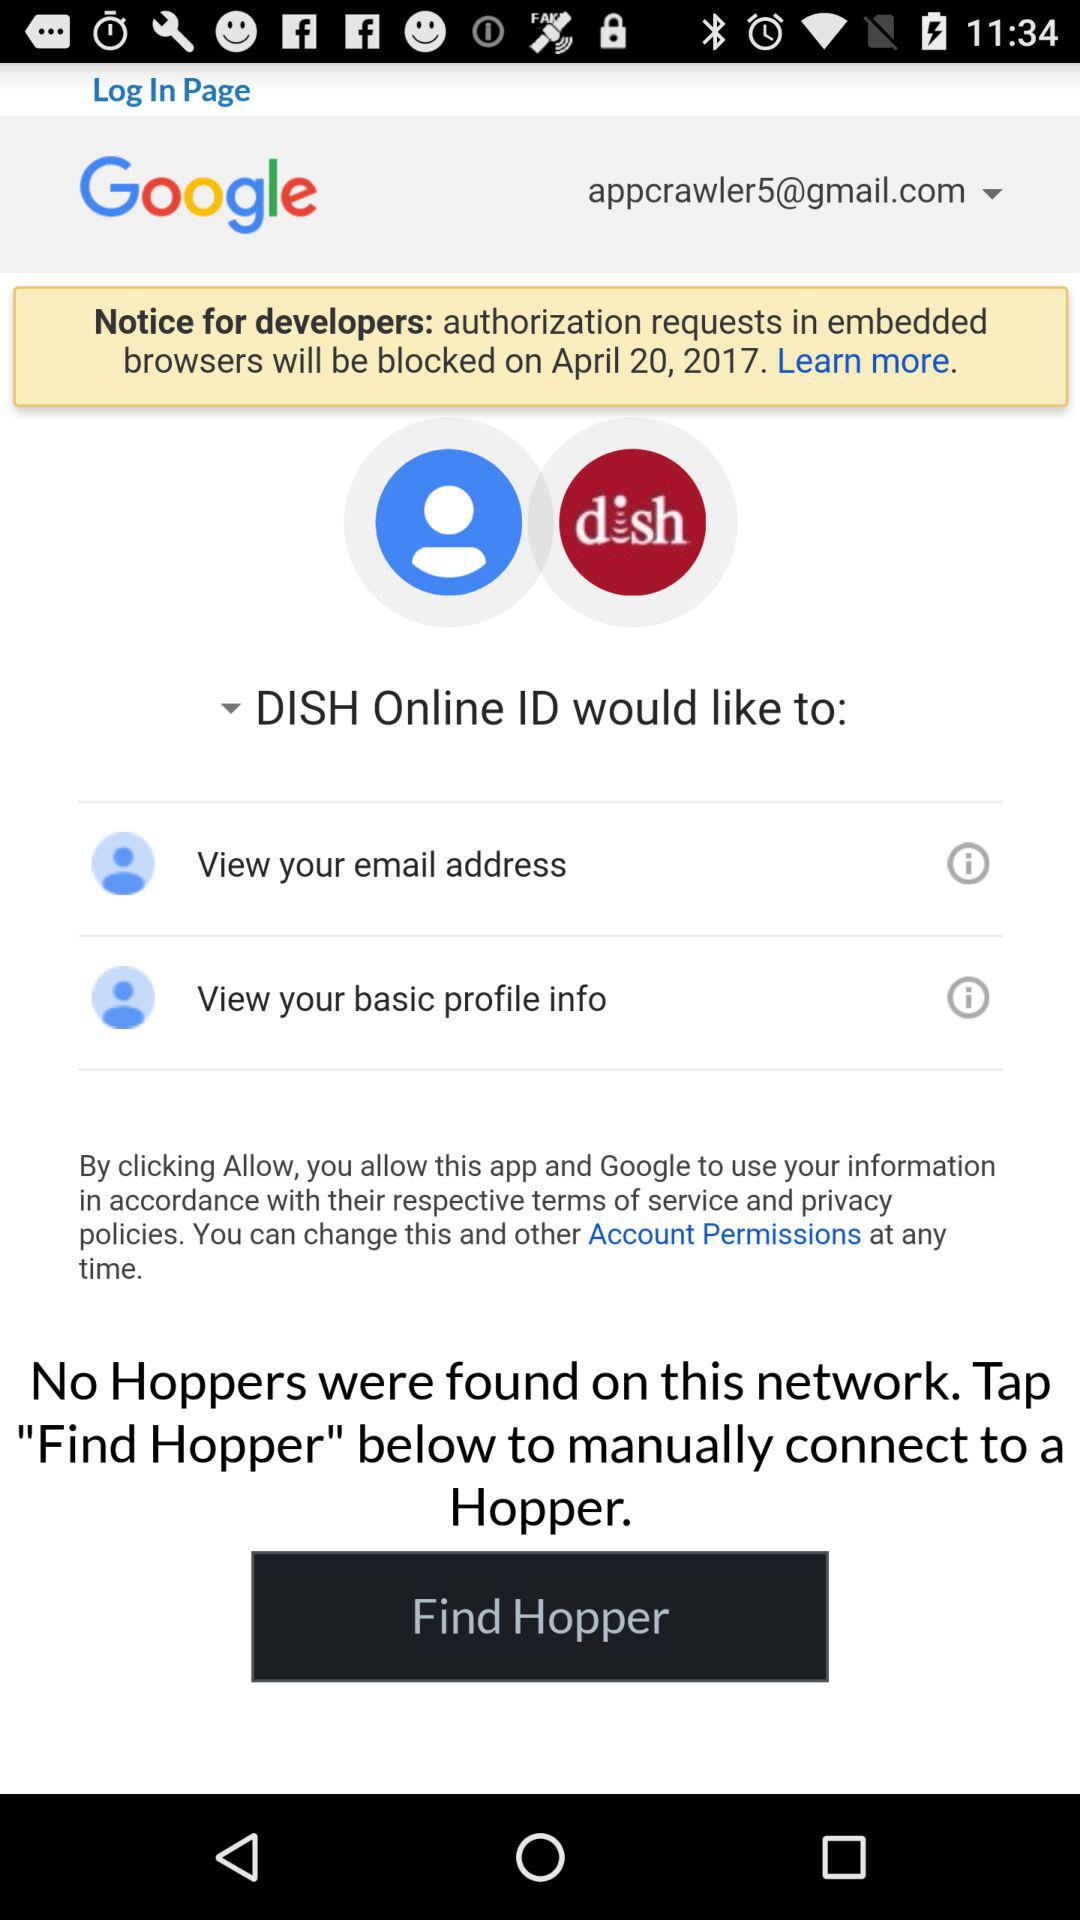What application is asking for permission? The application asking for permission is "DISH Online ID". 